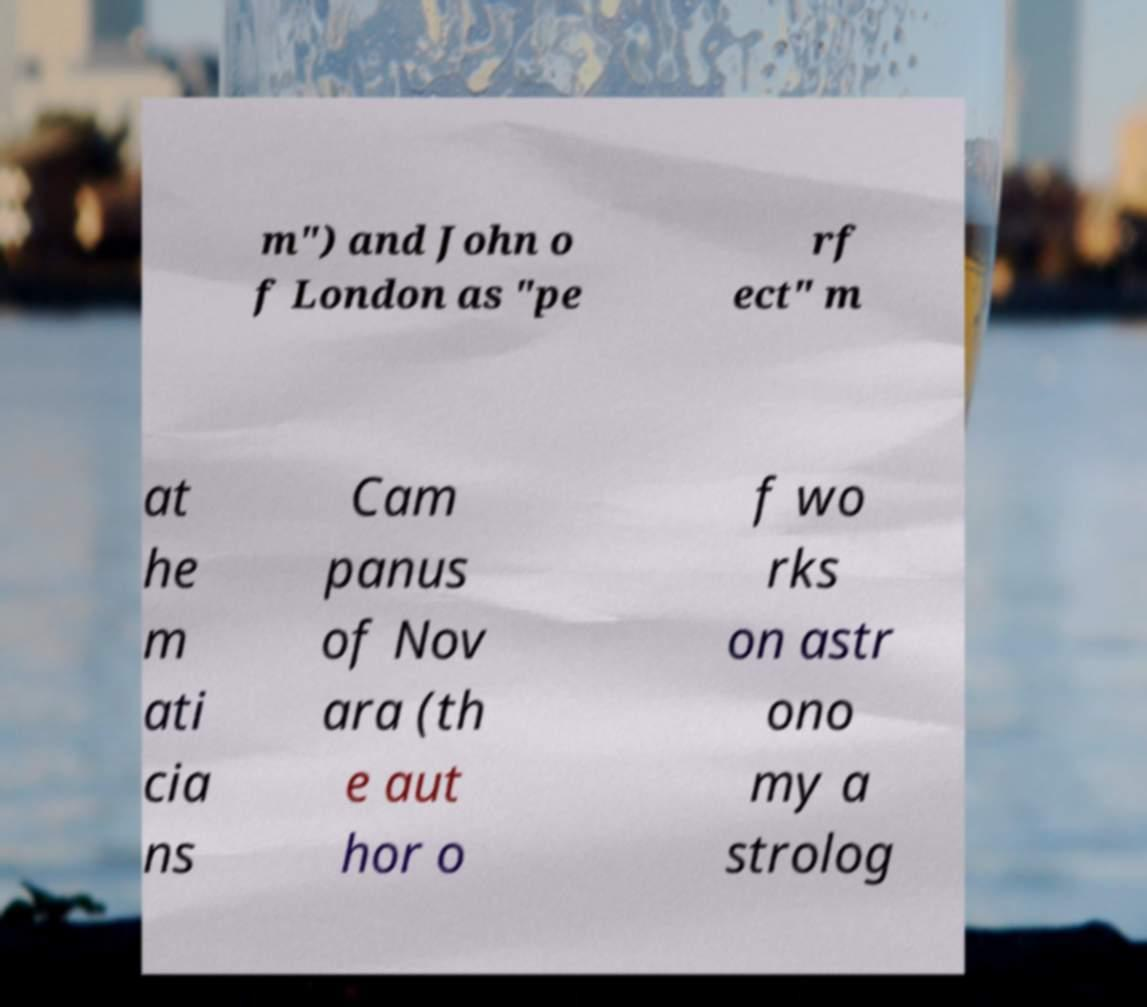Could you extract and type out the text from this image? m") and John o f London as "pe rf ect" m at he m ati cia ns Cam panus of Nov ara (th e aut hor o f wo rks on astr ono my a strolog 